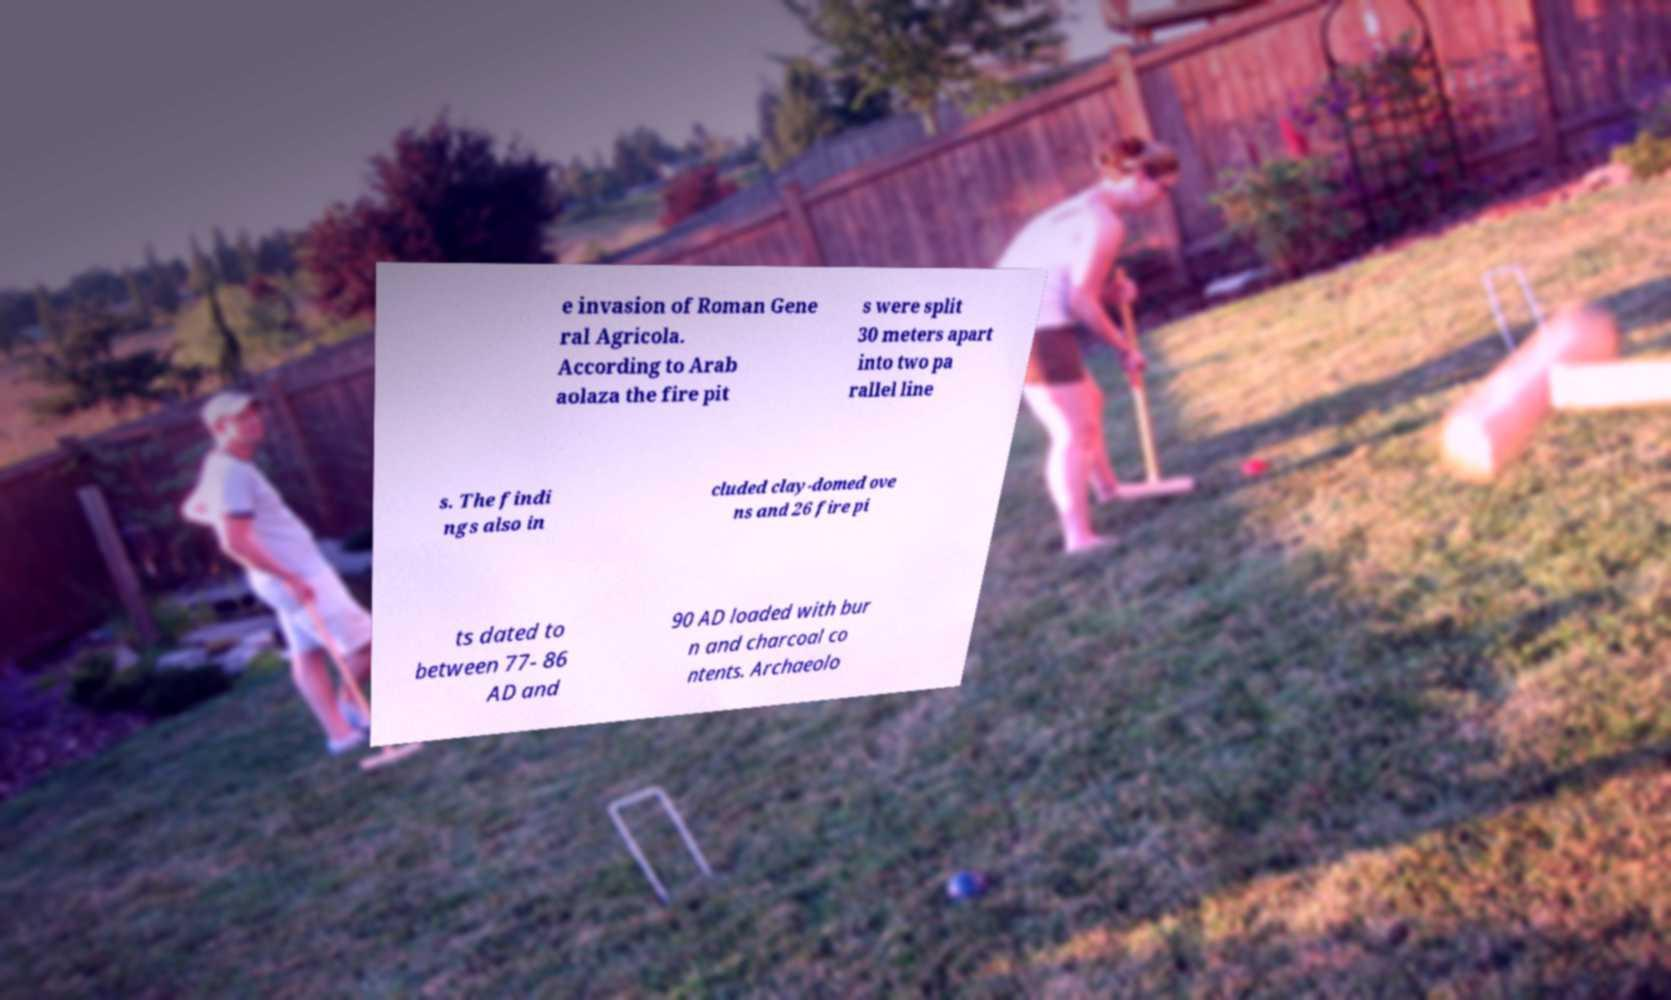Please read and relay the text visible in this image. What does it say? e invasion of Roman Gene ral Agricola. According to Arab aolaza the fire pit s were split 30 meters apart into two pa rallel line s. The findi ngs also in cluded clay-domed ove ns and 26 fire pi ts dated to between 77- 86 AD and 90 AD loaded with bur n and charcoal co ntents. Archaeolo 